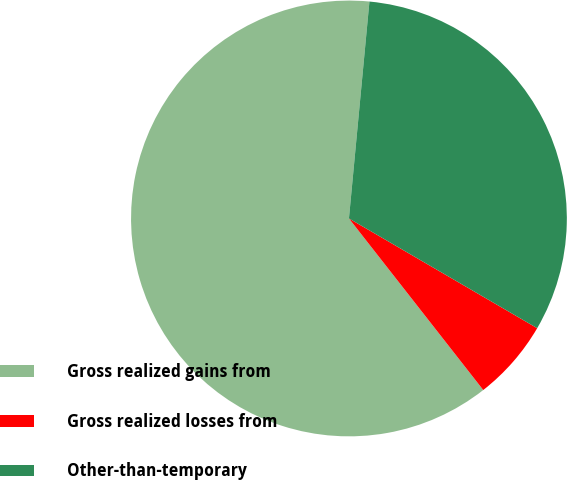<chart> <loc_0><loc_0><loc_500><loc_500><pie_chart><fcel>Gross realized gains from<fcel>Gross realized losses from<fcel>Other-than-temporary<nl><fcel>62.07%<fcel>6.03%<fcel>31.9%<nl></chart> 